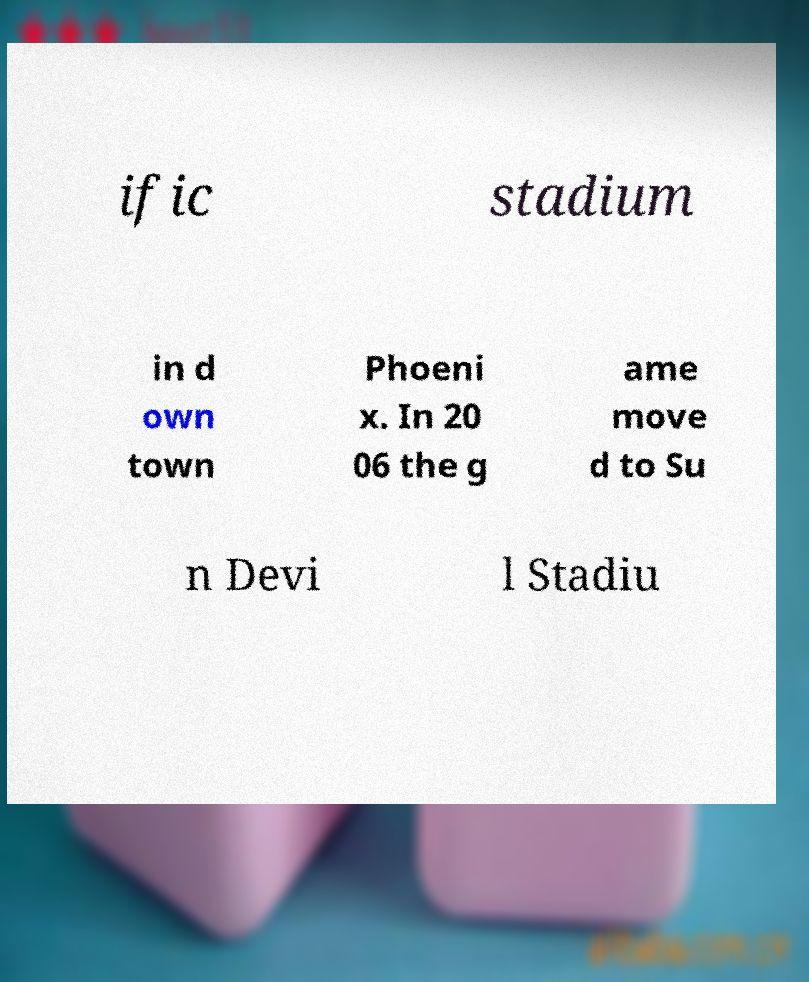For documentation purposes, I need the text within this image transcribed. Could you provide that? ific stadium in d own town Phoeni x. In 20 06 the g ame move d to Su n Devi l Stadiu 